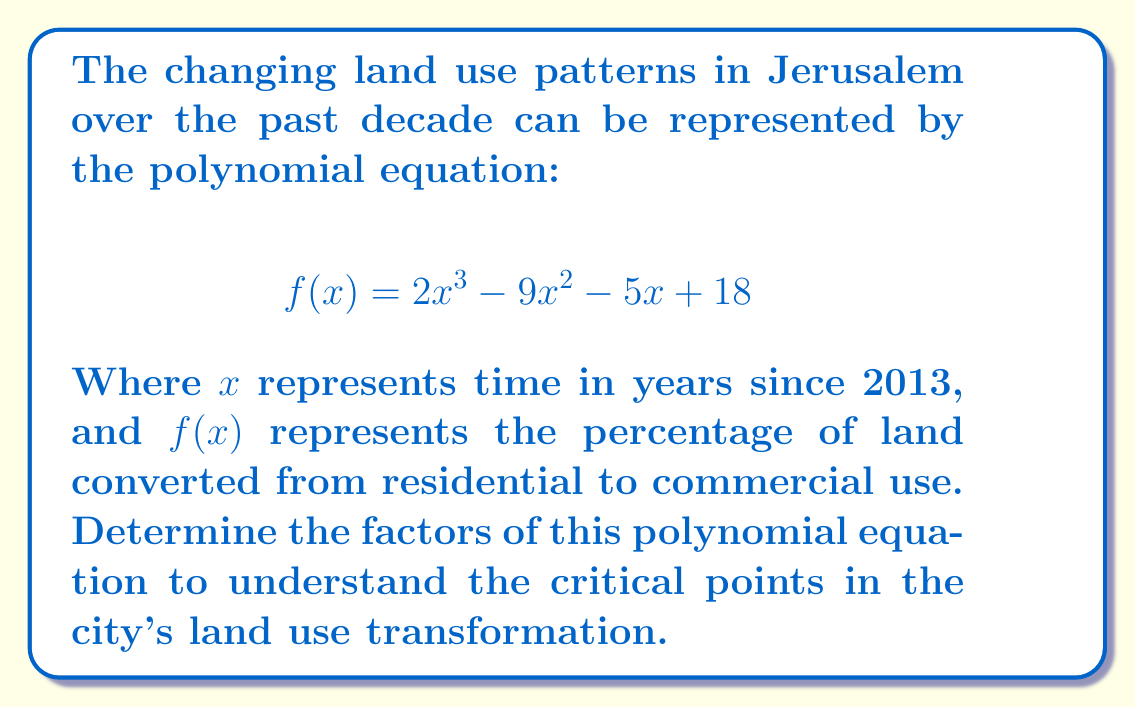What is the answer to this math problem? To factor this polynomial, we'll follow these steps:

1) First, check if there's a common factor. In this case, there isn't.

2) Next, we'll use the rational root theorem to find possible rational roots. The possible rational roots are the factors of the constant term (18): ±1, ±2, ±3, ±6, ±9, ±18.

3) Using synthetic division, we'll test these values:

   $f(1) = 2 - 9 - 5 + 18 = 6 \neq 0$
   $f(-1) = -2 + 9 - 5 + 18 = 20 \neq 0$
   $f(2) = 16 - 36 - 10 + 18 = -12 \neq 0$
   $f(3) = 54 - 81 - 15 + 18 = -24 \neq 0$
   $f(-3) = -54 + 81 - 15 + 18 = 30 \neq 0$
   $f(6) = 432 - 324 - 30 + 18 = 96 \neq 0$
   $f(-2) = -16 + 36 - 10 + 18 = 28 \neq 0$
   $f(9) = 1458 - 729 - 45 + 18 = 702 \neq 0$

4) We find that $f(-2) = 0$, so $(x+2)$ is a factor.

5) We can now use polynomial long division to divide $f(x)$ by $(x+2)$:

   $$\frac{2x^3 - 9x^2 - 5x + 18}{x + 2} = 2x^2 - 13x + 22$$

6) The resulting quadratic equation $2x^2 - 13x + 22$ can be factored using the quadratic formula or by inspection. We can see that it factors to $(2x-11)(x-2)$.

Therefore, the complete factorization is:

$$f(x) = (x+2)(2x-11)(x-2)$$
Answer: The factors of the polynomial $f(x) = 2x^3 - 9x^2 - 5x + 18$ are $(x+2)$, $(2x-11)$, and $(x-2)$. 